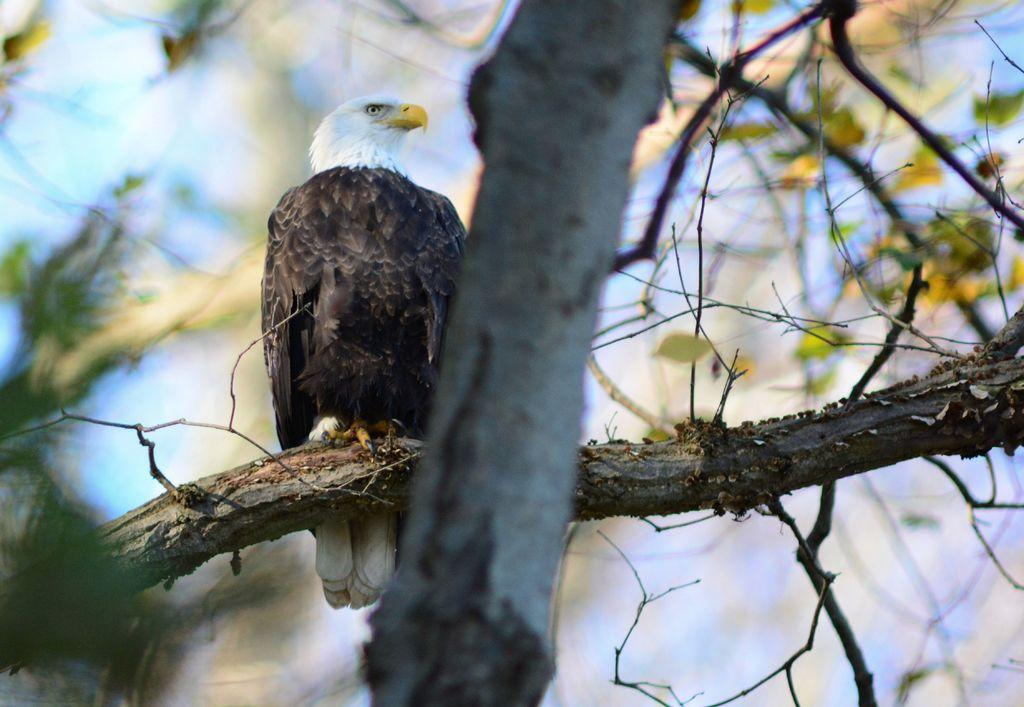What animal is the main subject of the image? There is an eagle in the image. What color is the eagle? The eagle is brown in color. Where is the eagle located in the image? The eagle is sitting on a tree branch. What type of lunch is the eagle eating in the image? There is no lunch present in the image; it only features an eagle sitting on a tree branch. 